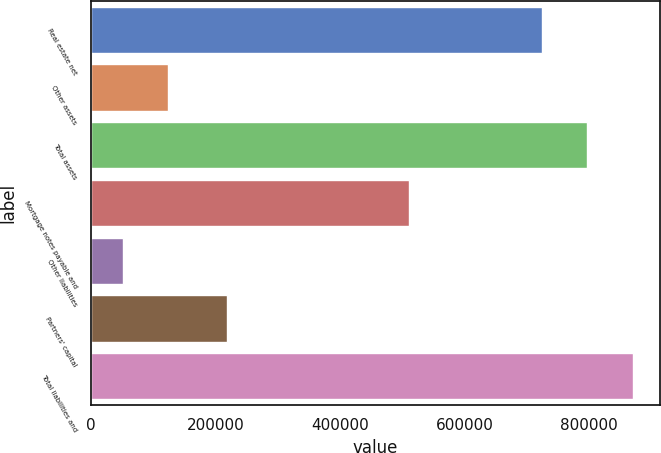<chart> <loc_0><loc_0><loc_500><loc_500><bar_chart><fcel>Real estate net<fcel>Other assets<fcel>Total assets<fcel>Mortgage notes payable and<fcel>Other liabilities<fcel>Partners' capital<fcel>Total liabilities and<nl><fcel>724795<fcel>124048<fcel>797735<fcel>510784<fcel>51108<fcel>218619<fcel>870676<nl></chart> 